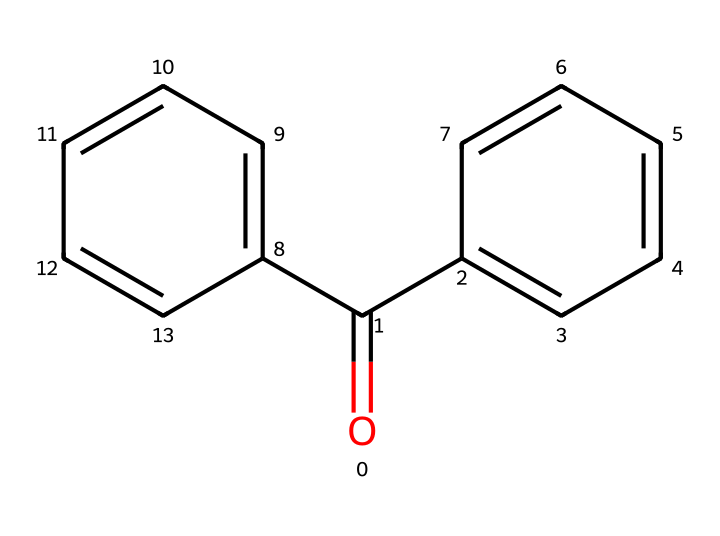What is the total number of carbon atoms in the chemical structure? The SMILES representation shows that there are two benzene rings, each containing six carbon atoms, and one additional carbon atom from the carbonyl group (O=C), leading to a total of 12 carbon atoms.
Answer: 12 How many double bonds are present in the structure? The structure includes double bonds between carbons within each benzene ring and one double bond in the carbonyl group (O=C). There are 7 double bonds in total (6 in the rings, 1 in the carbonyl).
Answer: 7 What is the main functional group present in this chemical? By analyzing the structure, the carbonyl group (C=O) is clearly visible, which is a significant functional group that defines its reactivity and properties.
Answer: carbonyl Which property makes benzophenone effective as a UV absorber? The presence of conjugated double bonds in the benzene rings allows it to absorb UV light efficiently. This conjugation system stabilizes the excited state of the molecule, enhancing its UV-absorbing capability.
Answer: conjugation Is benzophenone a solid, liquid, or gas at room temperature? The molecular structure suggests a solid state due to the rigid arrangement of aromatic rings, which typically results in a higher melting point. Benzophenone is known to be a solid at room temperature.
Answer: solid What type of chemical compound is benzophenone classified as? Benzophenone is classified as an aryl ketone, as it contains a carbonyl group attached to an aromatic ring structure. This reflects its reactivity and utility in various applications, including photoresists.
Answer: aryl ketone 